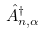<formula> <loc_0><loc_0><loc_500><loc_500>\hat { A } _ { n , \alpha } ^ { \dagger }</formula> 